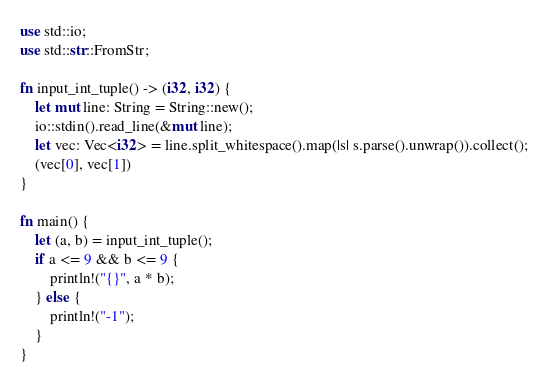Convert code to text. <code><loc_0><loc_0><loc_500><loc_500><_Rust_>use std::io;
use std::str::FromStr;

fn input_int_tuple() -> (i32, i32) {
    let mut line: String = String::new();
    io::stdin().read_line(&mut line);
    let vec: Vec<i32> = line.split_whitespace().map(|s| s.parse().unwrap()).collect();
    (vec[0], vec[1])
}

fn main() {
    let (a, b) = input_int_tuple();
    if a <= 9 && b <= 9 {
        println!("{}", a * b);
    } else {
        println!("-1");
    }
}
</code> 